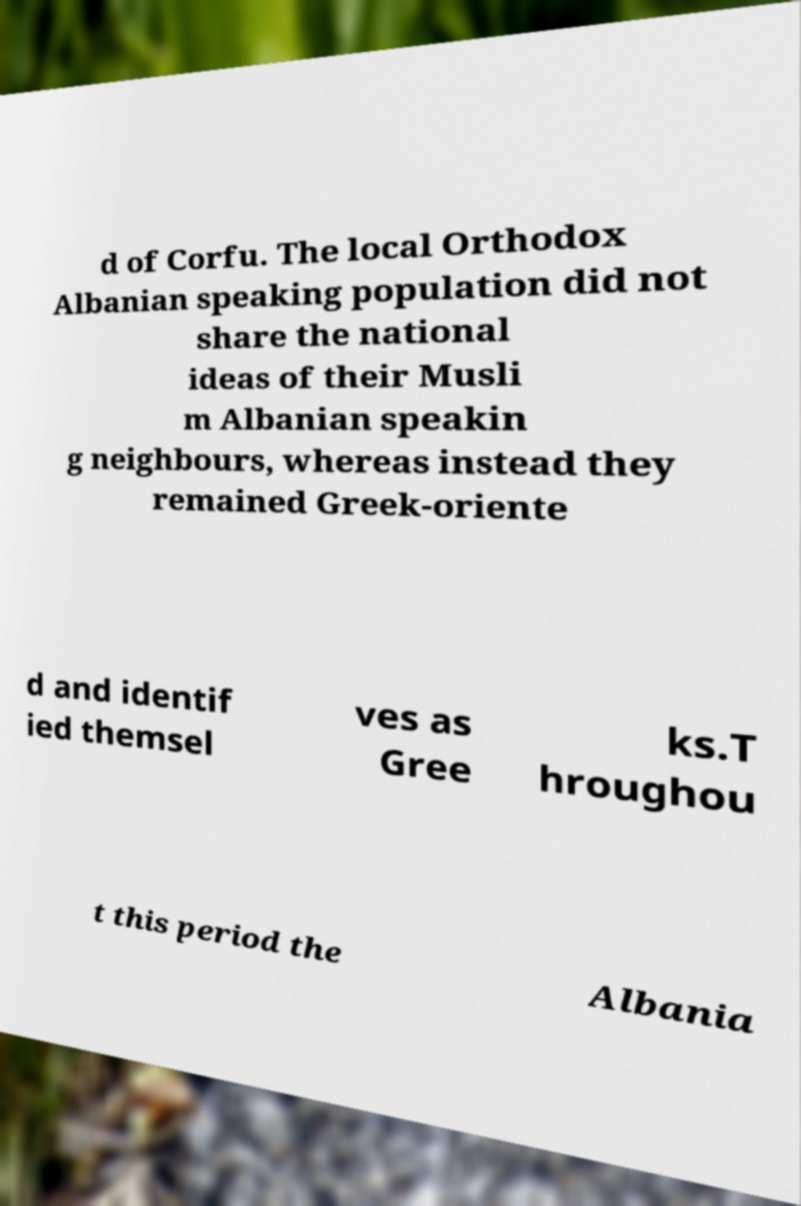Please read and relay the text visible in this image. What does it say? d of Corfu. The local Orthodox Albanian speaking population did not share the national ideas of their Musli m Albanian speakin g neighbours, whereas instead they remained Greek-oriente d and identif ied themsel ves as Gree ks.T hroughou t this period the Albania 